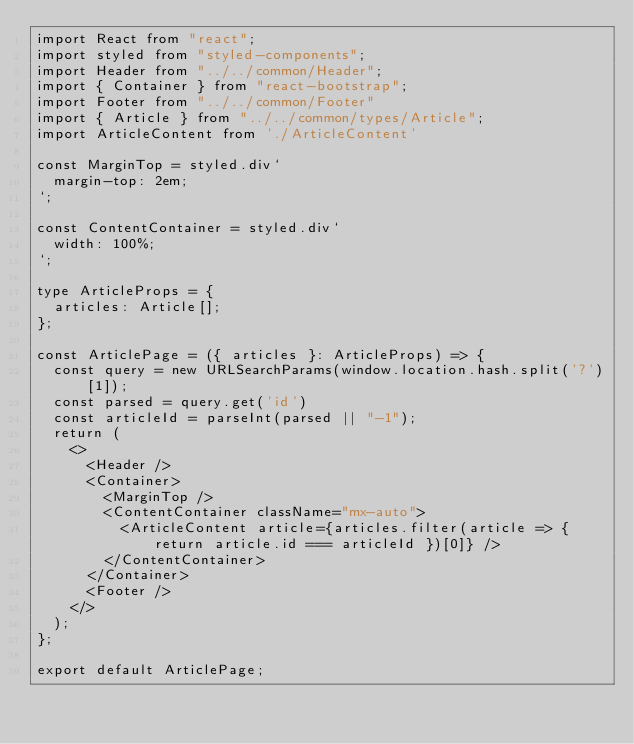<code> <loc_0><loc_0><loc_500><loc_500><_TypeScript_>import React from "react";
import styled from "styled-components";
import Header from "../../common/Header";
import { Container } from "react-bootstrap";
import Footer from "../../common/Footer"
import { Article } from "../../common/types/Article";
import ArticleContent from './ArticleContent'

const MarginTop = styled.div`
  margin-top: 2em;
`;

const ContentContainer = styled.div`
  width: 100%;
`;

type ArticleProps = {
  articles: Article[];
};

const ArticlePage = ({ articles }: ArticleProps) => {
  const query = new URLSearchParams(window.location.hash.split('?')[1]);
  const parsed = query.get('id')
  const articleId = parseInt(parsed || "-1");
  return (
    <>
      <Header />
      <Container>
        <MarginTop />
        <ContentContainer className="mx-auto">
          <ArticleContent article={articles.filter(article => { return article.id === articleId })[0]} />
        </ContentContainer>
      </Container>
      <Footer />
    </>
  );
};

export default ArticlePage;
</code> 